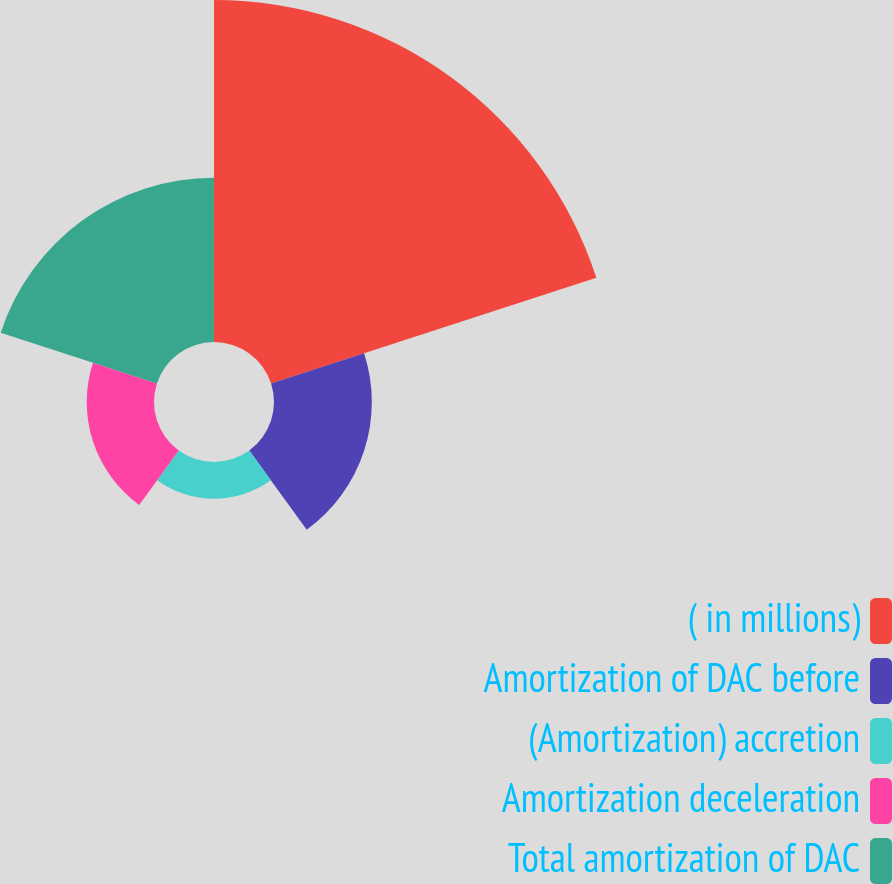Convert chart to OTSL. <chart><loc_0><loc_0><loc_500><loc_500><pie_chart><fcel>( in millions)<fcel>Amortization of DAC before<fcel>(Amortization) accretion<fcel>Amortization deceleration<fcel>Total amortization of DAC<nl><fcel>48.29%<fcel>13.81%<fcel>5.19%<fcel>9.5%<fcel>23.2%<nl></chart> 